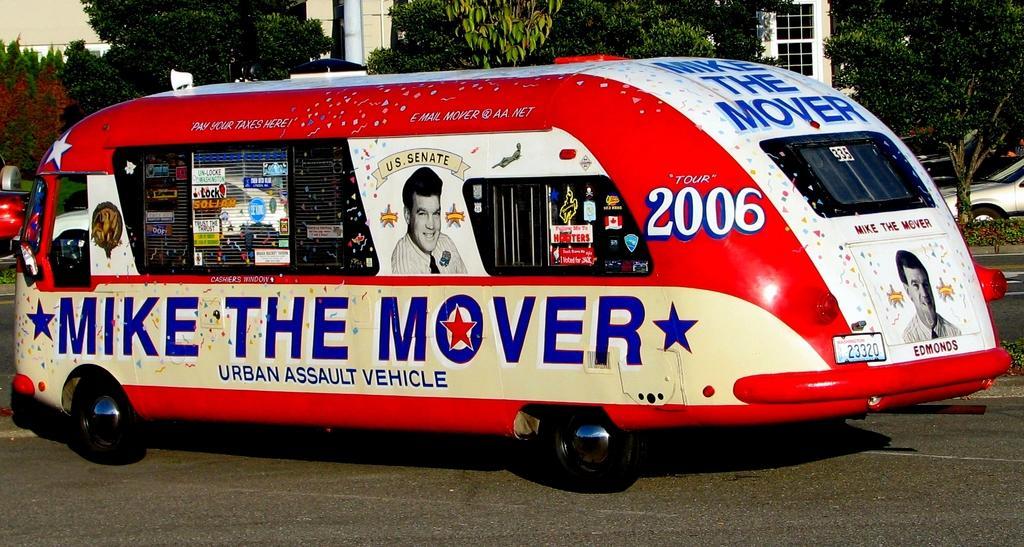Can you describe this image briefly? In this image we can see a vehicle which is in different colors like red, white, blue and yellow moving on road and in the background of the image there are some trees and vehicles on road. 